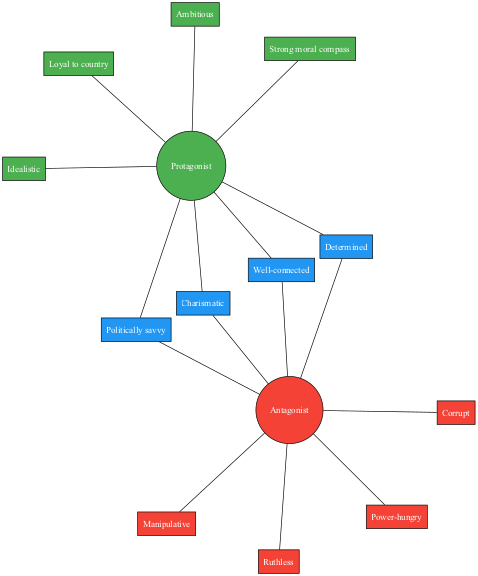What are two traits of the protagonist? The diagram lists "Idealistic" and "Loyal to country" as traits of the protagonist. Both traits are placed within the 'Protagonist' circle.
Answer: Idealistic, Loyal to country How many shared traits are there? By examining the section of the diagram where shared traits are displayed, there are four traits listed. This can be counted directly from the shared traits section.
Answer: 4 What trait is associated with the antagonist that shows a lack of ethical boundaries? The term "Ruthless" is linked with the antagonist in the diagram, reflecting a characteristic that indicates a disregard for morality. This trait is found within the 'Antagonist' circle.
Answer: Ruthless Which trait do both the protagonist and antagonist share that indicates they both have influence? The trait "Politically savvy" is highlighted in the diagram as a trait that exists in the shared section, indicating both characters possess this quality. This can be seen in the intersection of the two circles.
Answer: Politically savvy What is a primary difference between the protagonist and antagonist as shown in the diagram? The protagonist is described as "Strong moral compass," a trait not found among the antagonist's traits. This highlights a stark moral difference presented visually in their respective circles.
Answer: Strong moral compass List the color associated with the protagonist in the diagram. The diagram uses a distinct color to represent the protagonist, specifically green. This color is noted in the 'Protagonist' section.
Answer: Green Which character trait is attributed solely to the antagonist? The trait "Corrupt" is uniquely associated with the antagonist and is not shared with the protagonist according to the diagram. It can be found strictly within the 'Antagonist' circle.
Answer: Corrupt How many traits are displayed for the antagonist? By reviewing the 'Antagonist' circle in the diagram, there are four distinct traits listed for the antagonist. These traits can be counted directly.
Answer: 4 What characterizes the relationship between "Determined" and the shared traits? The trait "Determined" is listed among the shared traits, indicating that both the protagonist and antagonist possess this quality, which is found in the overlap of the two circles.
Answer: Shared trait 